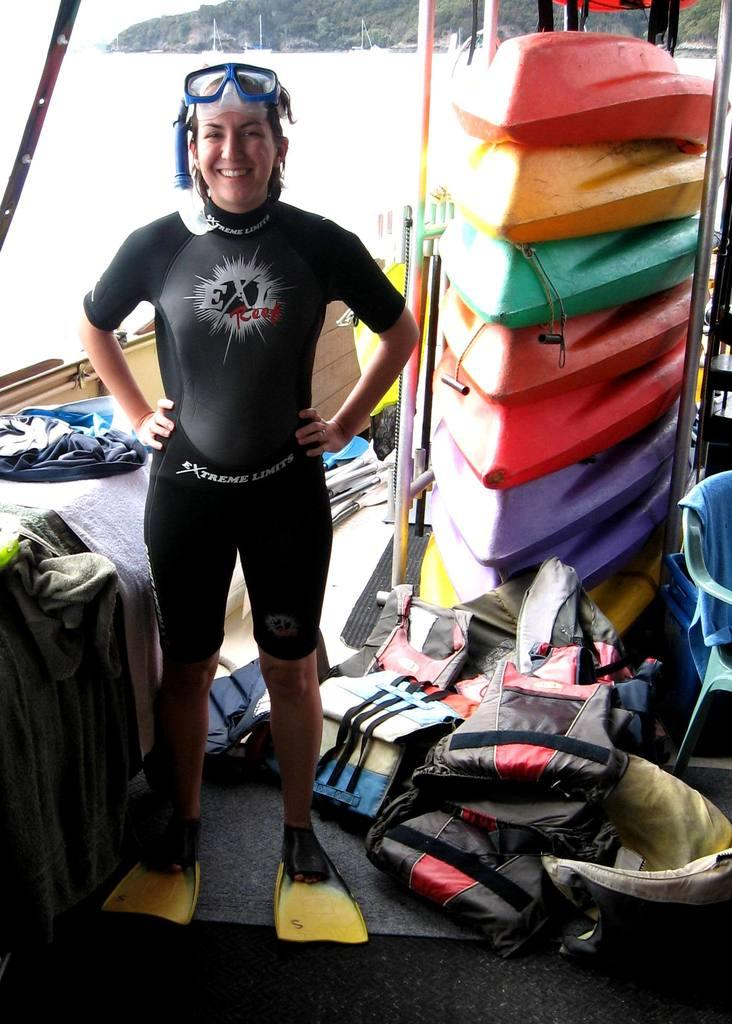<image>
Summarize the visual content of the image. A person in a wet suit and flippers, standing in front of a stack of kayaks 